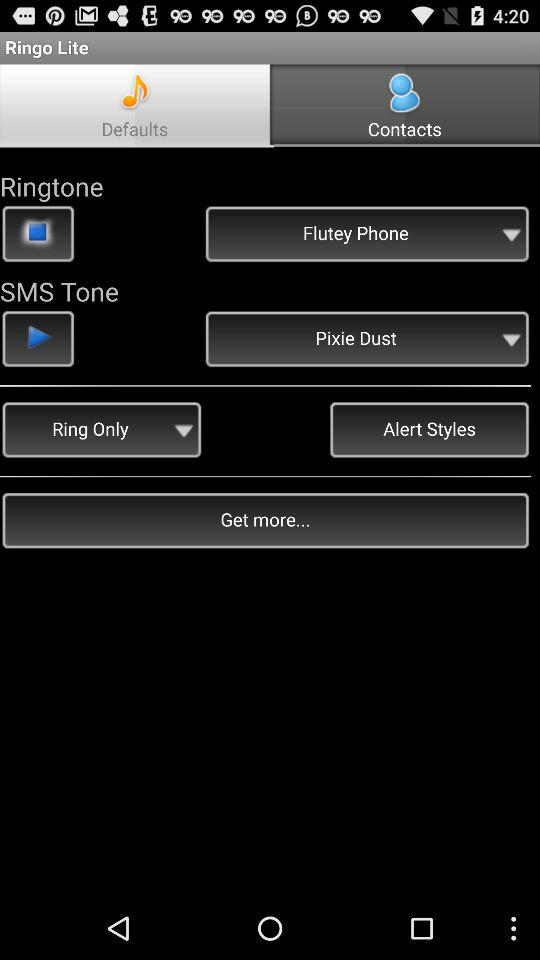What is the setting for SMS tone? The setting for SMS tone is "Pixie Dust". 